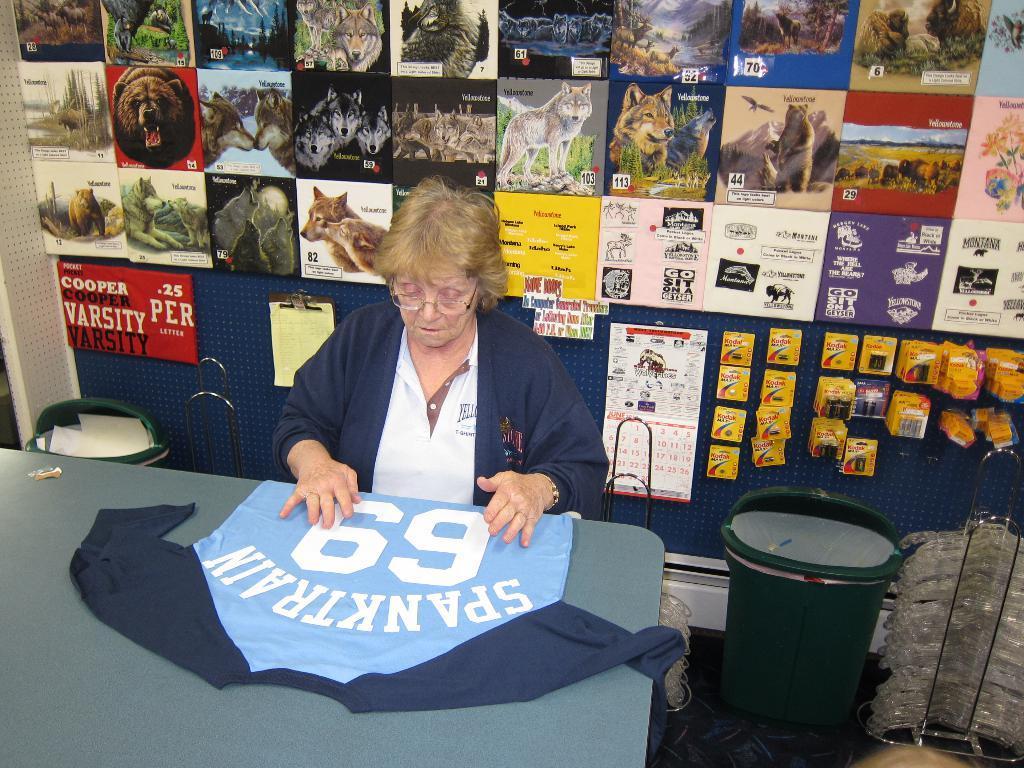Could you give a brief overview of what you see in this image? In this image in the front there is a table, on the table there is a cloth. In the center there is a woman sitting and on the right side there is a bin which is green in colour. In the background there are posters on the wall some text and images on it and in front of the wall, on the left side there is a dustbin. On the right side there is an object which is brown in colour. 